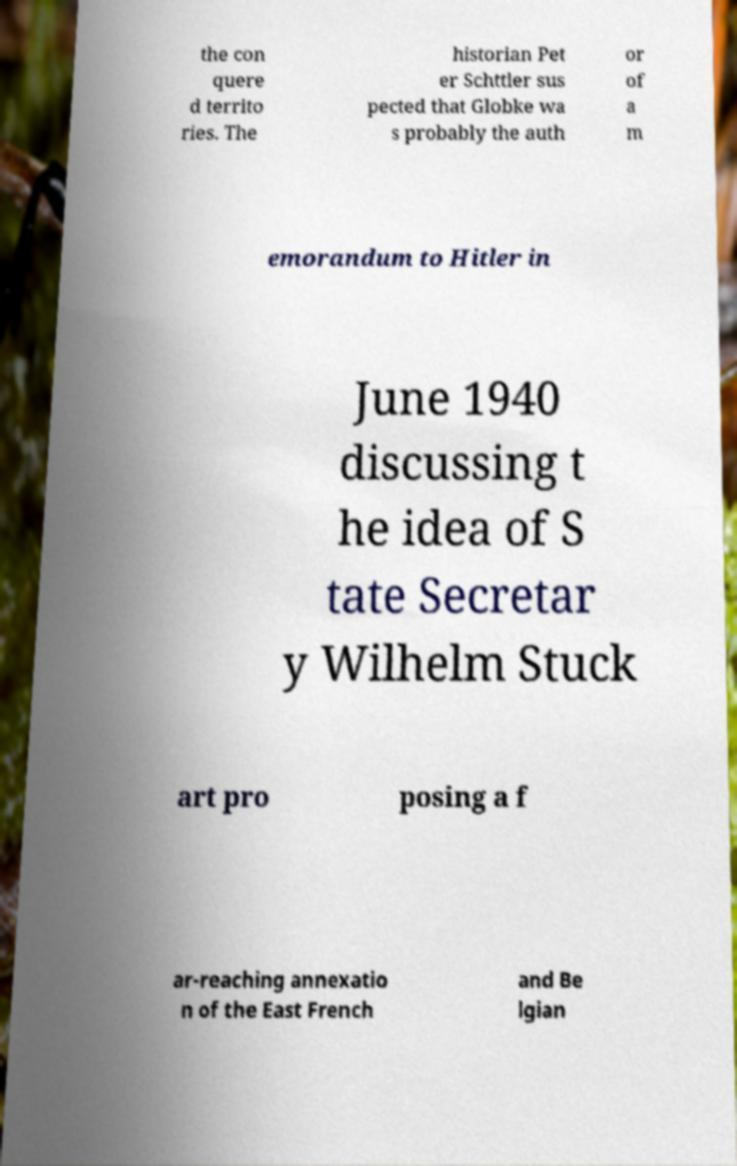Could you assist in decoding the text presented in this image and type it out clearly? the con quere d territo ries. The historian Pet er Schttler sus pected that Globke wa s probably the auth or of a m emorandum to Hitler in June 1940 discussing t he idea of S tate Secretar y Wilhelm Stuck art pro posing a f ar-reaching annexatio n of the East French and Be lgian 